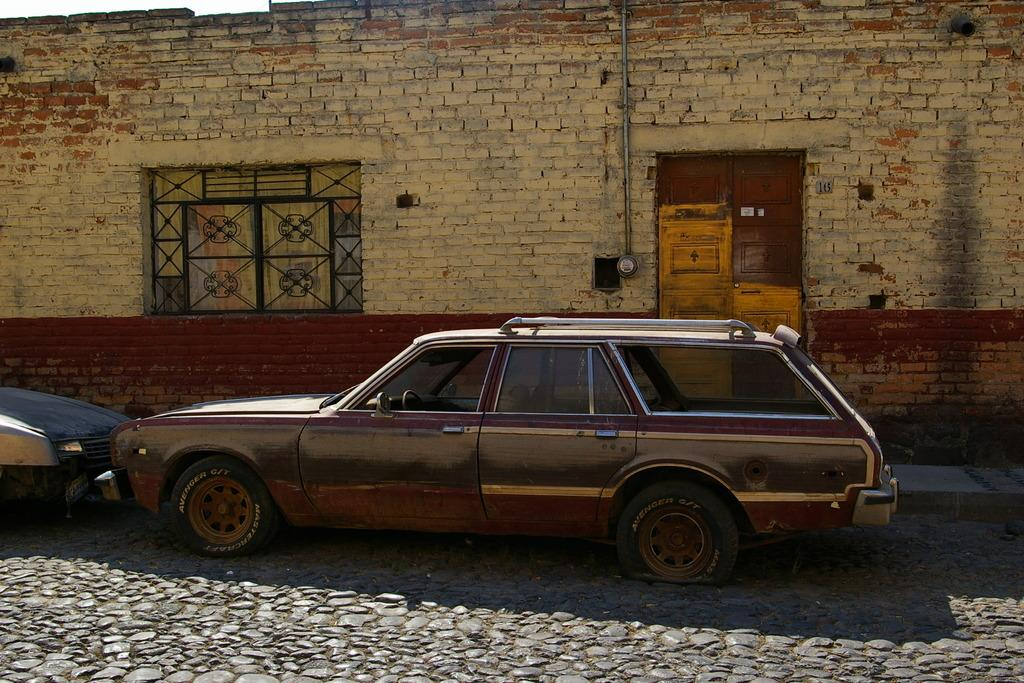What can be seen on the road in the image? There are two vehicles parked on the road. What is located behind the vehicles? There is a house behind the vehicles. What features does the house have? The house has a door and a window. Is there any additional infrastructure associated with the house? Yes, there is a pipe associated with the house. What type of secretary can be seen working in the house in the image? There is no secretary present in the image; it only shows two vehicles parked on the road and a house with a door, window, and pipe. How does the boot feel about being in the image? There is no boot present in the image, so it is not possible to determine how it might feel. 